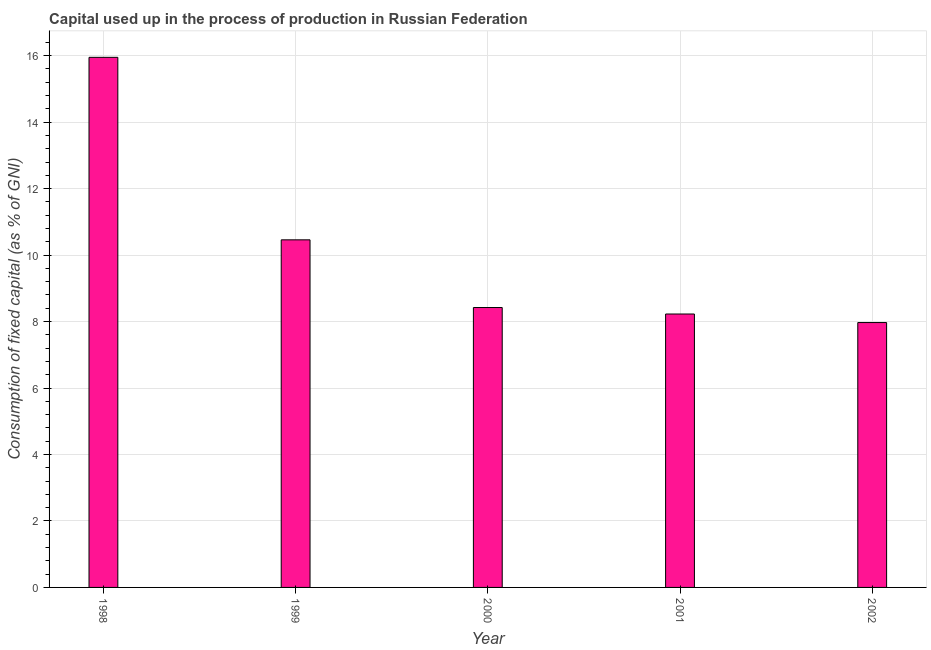Does the graph contain any zero values?
Keep it short and to the point. No. Does the graph contain grids?
Give a very brief answer. Yes. What is the title of the graph?
Your response must be concise. Capital used up in the process of production in Russian Federation. What is the label or title of the X-axis?
Ensure brevity in your answer.  Year. What is the label or title of the Y-axis?
Provide a short and direct response. Consumption of fixed capital (as % of GNI). What is the consumption of fixed capital in 1999?
Provide a short and direct response. 10.46. Across all years, what is the maximum consumption of fixed capital?
Ensure brevity in your answer.  15.95. Across all years, what is the minimum consumption of fixed capital?
Your answer should be very brief. 7.97. In which year was the consumption of fixed capital maximum?
Keep it short and to the point. 1998. In which year was the consumption of fixed capital minimum?
Keep it short and to the point. 2002. What is the sum of the consumption of fixed capital?
Provide a succinct answer. 51.03. What is the difference between the consumption of fixed capital in 1999 and 2001?
Provide a succinct answer. 2.23. What is the average consumption of fixed capital per year?
Provide a succinct answer. 10.21. What is the median consumption of fixed capital?
Ensure brevity in your answer.  8.42. Do a majority of the years between 1999 and 2001 (inclusive) have consumption of fixed capital greater than 6.4 %?
Provide a succinct answer. Yes. What is the ratio of the consumption of fixed capital in 1998 to that in 2001?
Offer a terse response. 1.94. Is the difference between the consumption of fixed capital in 1999 and 2000 greater than the difference between any two years?
Offer a very short reply. No. What is the difference between the highest and the second highest consumption of fixed capital?
Your response must be concise. 5.49. Is the sum of the consumption of fixed capital in 1998 and 2000 greater than the maximum consumption of fixed capital across all years?
Your answer should be compact. Yes. What is the difference between the highest and the lowest consumption of fixed capital?
Provide a short and direct response. 7.98. Are all the bars in the graph horizontal?
Offer a very short reply. No. How many years are there in the graph?
Give a very brief answer. 5. What is the difference between two consecutive major ticks on the Y-axis?
Make the answer very short. 2. Are the values on the major ticks of Y-axis written in scientific E-notation?
Keep it short and to the point. No. What is the Consumption of fixed capital (as % of GNI) of 1998?
Keep it short and to the point. 15.95. What is the Consumption of fixed capital (as % of GNI) in 1999?
Your answer should be compact. 10.46. What is the Consumption of fixed capital (as % of GNI) in 2000?
Your answer should be compact. 8.42. What is the Consumption of fixed capital (as % of GNI) of 2001?
Ensure brevity in your answer.  8.23. What is the Consumption of fixed capital (as % of GNI) of 2002?
Ensure brevity in your answer.  7.97. What is the difference between the Consumption of fixed capital (as % of GNI) in 1998 and 1999?
Your answer should be very brief. 5.49. What is the difference between the Consumption of fixed capital (as % of GNI) in 1998 and 2000?
Provide a short and direct response. 7.53. What is the difference between the Consumption of fixed capital (as % of GNI) in 1998 and 2001?
Give a very brief answer. 7.72. What is the difference between the Consumption of fixed capital (as % of GNI) in 1998 and 2002?
Your answer should be compact. 7.98. What is the difference between the Consumption of fixed capital (as % of GNI) in 1999 and 2000?
Offer a terse response. 2.04. What is the difference between the Consumption of fixed capital (as % of GNI) in 1999 and 2001?
Make the answer very short. 2.23. What is the difference between the Consumption of fixed capital (as % of GNI) in 1999 and 2002?
Keep it short and to the point. 2.49. What is the difference between the Consumption of fixed capital (as % of GNI) in 2000 and 2001?
Your response must be concise. 0.2. What is the difference between the Consumption of fixed capital (as % of GNI) in 2000 and 2002?
Offer a very short reply. 0.45. What is the difference between the Consumption of fixed capital (as % of GNI) in 2001 and 2002?
Give a very brief answer. 0.26. What is the ratio of the Consumption of fixed capital (as % of GNI) in 1998 to that in 1999?
Keep it short and to the point. 1.52. What is the ratio of the Consumption of fixed capital (as % of GNI) in 1998 to that in 2000?
Make the answer very short. 1.89. What is the ratio of the Consumption of fixed capital (as % of GNI) in 1998 to that in 2001?
Provide a succinct answer. 1.94. What is the ratio of the Consumption of fixed capital (as % of GNI) in 1998 to that in 2002?
Your answer should be compact. 2. What is the ratio of the Consumption of fixed capital (as % of GNI) in 1999 to that in 2000?
Give a very brief answer. 1.24. What is the ratio of the Consumption of fixed capital (as % of GNI) in 1999 to that in 2001?
Provide a short and direct response. 1.27. What is the ratio of the Consumption of fixed capital (as % of GNI) in 1999 to that in 2002?
Your response must be concise. 1.31. What is the ratio of the Consumption of fixed capital (as % of GNI) in 2000 to that in 2001?
Offer a very short reply. 1.02. What is the ratio of the Consumption of fixed capital (as % of GNI) in 2000 to that in 2002?
Provide a succinct answer. 1.06. What is the ratio of the Consumption of fixed capital (as % of GNI) in 2001 to that in 2002?
Keep it short and to the point. 1.03. 